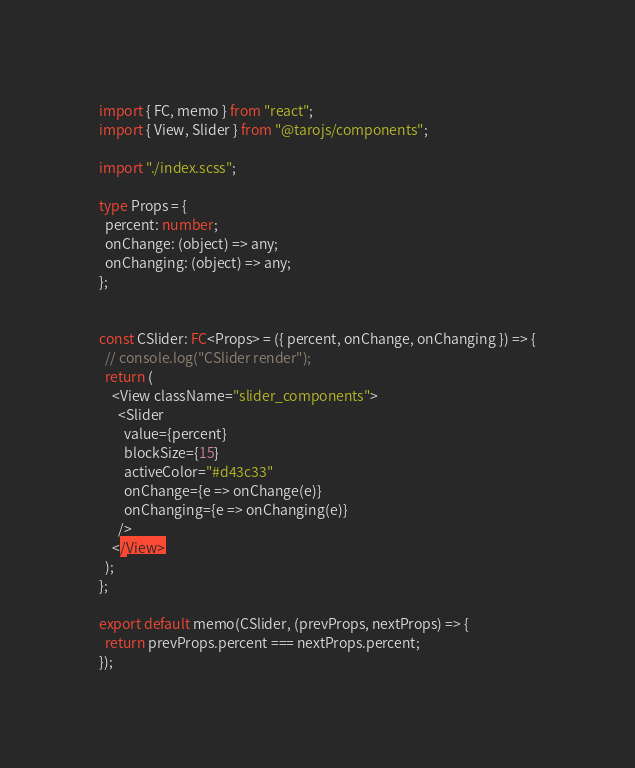<code> <loc_0><loc_0><loc_500><loc_500><_TypeScript_>import { FC, memo } from "react";
import { View, Slider } from "@tarojs/components";

import "./index.scss";

type Props = {
  percent: number;
  onChange: (object) => any;
  onChanging: (object) => any;
};


const CSlider: FC<Props> = ({ percent, onChange, onChanging }) => {
  // console.log("CSlider render");
  return (
    <View className="slider_components">
      <Slider
        value={percent}
        blockSize={15}
        activeColor="#d43c33"
        onChange={e => onChange(e)}
        onChanging={e => onChanging(e)}
      />
    </View>
  );
};

export default memo(CSlider, (prevProps, nextProps) => {
  return prevProps.percent === nextProps.percent;
});
</code> 